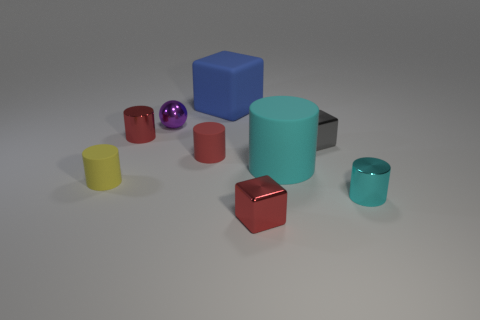How many tiny gray cubes are on the right side of the tiny cyan shiny thing?
Give a very brief answer. 0. What number of small objects have the same color as the big cylinder?
Your answer should be compact. 1. Does the small red cylinder left of the metal ball have the same material as the large cyan cylinder?
Provide a short and direct response. No. What number of small yellow things have the same material as the large blue object?
Offer a terse response. 1. Are there more gray shiny objects that are on the left side of the large cyan rubber cylinder than tiny cyan metal cylinders?
Your answer should be compact. No. What size is the other metal cylinder that is the same color as the large cylinder?
Your answer should be compact. Small. Are there any small cyan metallic objects that have the same shape as the gray object?
Your answer should be compact. No. What number of objects are either purple things or cyan metal cylinders?
Offer a very short reply. 2. What number of large blue cubes are in front of the red object in front of the big thing in front of the small purple ball?
Offer a terse response. 0. What material is the small cyan thing that is the same shape as the tiny red rubber object?
Give a very brief answer. Metal. 